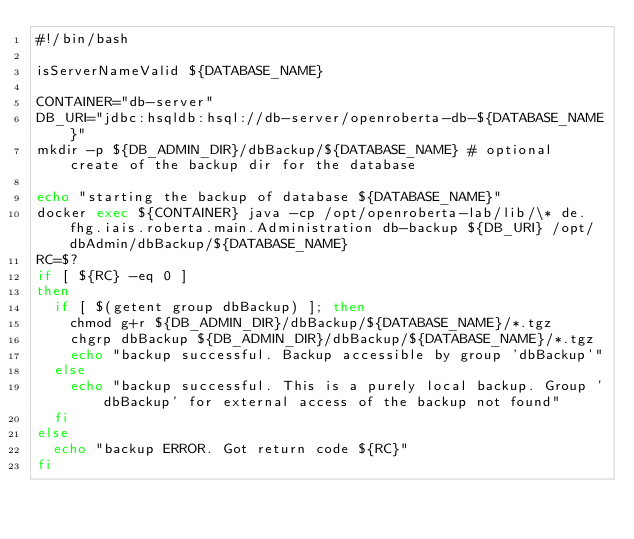<code> <loc_0><loc_0><loc_500><loc_500><_Bash_>#!/bin/bash

isServerNameValid ${DATABASE_NAME}

CONTAINER="db-server"
DB_URI="jdbc:hsqldb:hsql://db-server/openroberta-db-${DATABASE_NAME}"
mkdir -p ${DB_ADMIN_DIR}/dbBackup/${DATABASE_NAME} # optional create of the backup dir for the database

echo "starting the backup of database ${DATABASE_NAME}"
docker exec ${CONTAINER} java -cp /opt/openroberta-lab/lib/\* de.fhg.iais.roberta.main.Administration db-backup ${DB_URI} /opt/dbAdmin/dbBackup/${DATABASE_NAME}
RC=$?
if [ ${RC} -eq 0 ]
then
  if [ $(getent group dbBackup) ]; then
    chmod g+r ${DB_ADMIN_DIR}/dbBackup/${DATABASE_NAME}/*.tgz
    chgrp dbBackup ${DB_ADMIN_DIR}/dbBackup/${DATABASE_NAME}/*.tgz
    echo "backup successful. Backup accessible by group 'dbBackup'"
  else
    echo "backup successful. This is a purely local backup. Group 'dbBackup' for external access of the backup not found"
  fi
else
  echo "backup ERROR. Got return code ${RC}"
fi</code> 